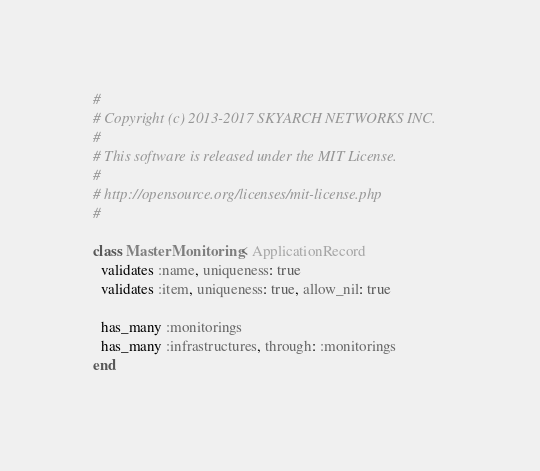<code> <loc_0><loc_0><loc_500><loc_500><_Ruby_>#
# Copyright (c) 2013-2017 SKYARCH NETWORKS INC.
#
# This software is released under the MIT License.
#
# http://opensource.org/licenses/mit-license.php
#

class MasterMonitoring < ApplicationRecord
  validates :name, uniqueness: true
  validates :item, uniqueness: true, allow_nil: true

  has_many :monitorings
  has_many :infrastructures, through: :monitorings
end
</code> 